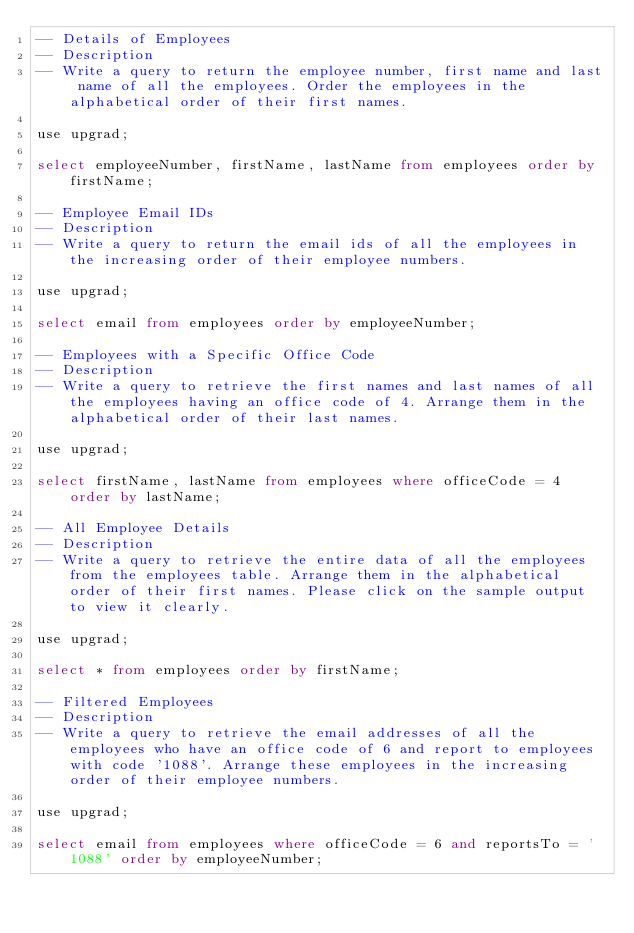<code> <loc_0><loc_0><loc_500><loc_500><_SQL_>-- Details of Employees
-- Description
-- Write a query to return the employee number, first name and last name of all the employees. Order the employees in the alphabetical order of their first names.

use upgrad;

select employeeNumber, firstName, lastName from employees order by firstName;

-- Employee Email IDs
-- Description
-- Write a query to return the email ids of all the employees in the increasing order of their employee numbers.

use upgrad;

select email from employees order by employeeNumber;

-- Employees with a Specific Office Code
-- Description
-- Write a query to retrieve the first names and last names of all the employees having an office code of 4. Arrange them in the alphabetical order of their last names.

use upgrad;

select firstName, lastName from employees where officeCode = 4 order by lastName;

-- All Employee Details
-- Description
-- Write a query to retrieve the entire data of all the employees from the employees table. Arrange them in the alphabetical order of their first names. Please click on the sample output to view it clearly.

use upgrad;

select * from employees order by firstName;

-- Filtered Employees
-- Description
-- Write a query to retrieve the email addresses of all the employees who have an office code of 6 and report to employees with code '1088'. Arrange these employees in the increasing order of their employee numbers.

use upgrad;

select email from employees where officeCode = 6 and reportsTo = '1088' order by employeeNumber;

</code> 